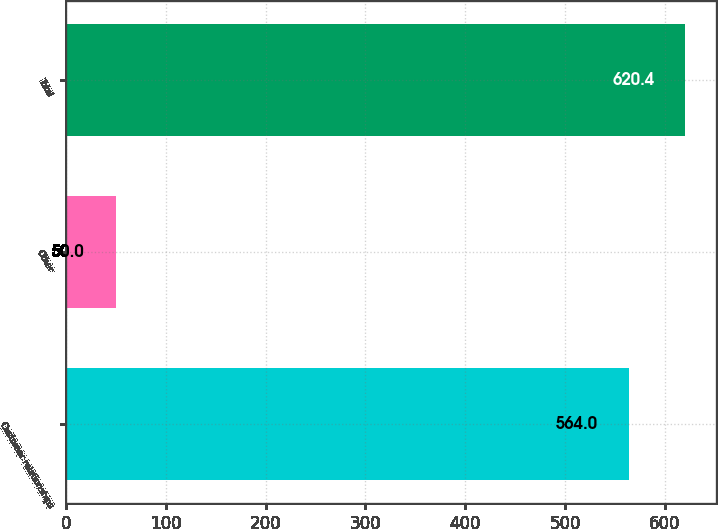<chart> <loc_0><loc_0><loc_500><loc_500><bar_chart><fcel>Customer relationships<fcel>Other<fcel>Total<nl><fcel>564<fcel>50<fcel>620.4<nl></chart> 